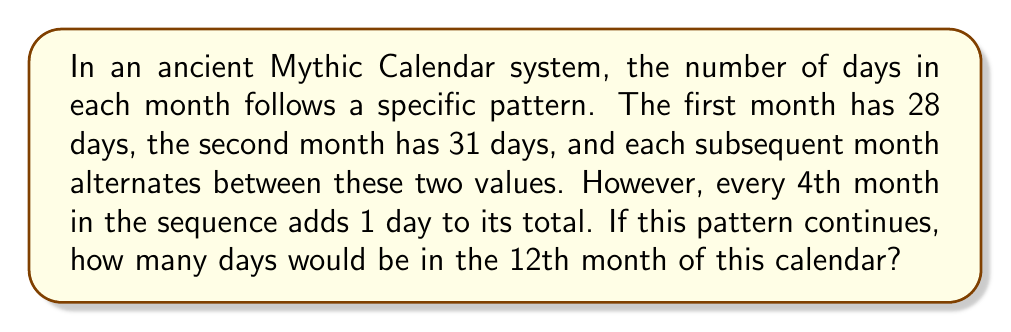Teach me how to tackle this problem. Let's break this down step-by-step:

1) First, let's write out the pattern for the first few months:
   Month 1: 28 days
   Month 2: 31 days
   Month 3: 28 days
   Month 4: 31 + 1 = 32 days (because it's the 4th month)
   Month 5: 28 days
   Month 6: 31 days
   Month 7: 28 days
   Month 8: 31 + 1 = 32 days (because it's the 8th month)

2) We can see that the pattern repeats every 4 months, with the 4th month always getting an extra day.

3) To find the 12th month, we can divide 12 by 4:
   $12 \div 4 = 3$

4) This means that the 12th month is at the end of the third complete cycle.

5) In each cycle, the months follow the pattern: 28, 31, 28, 32

6) The 12th month corresponds to the 4th position in its cycle.

7) The 4th position in the cycle always has 32 days.

Therefore, the 12th month in this Mythic Calendar would have 32 days.
Answer: 32 days 